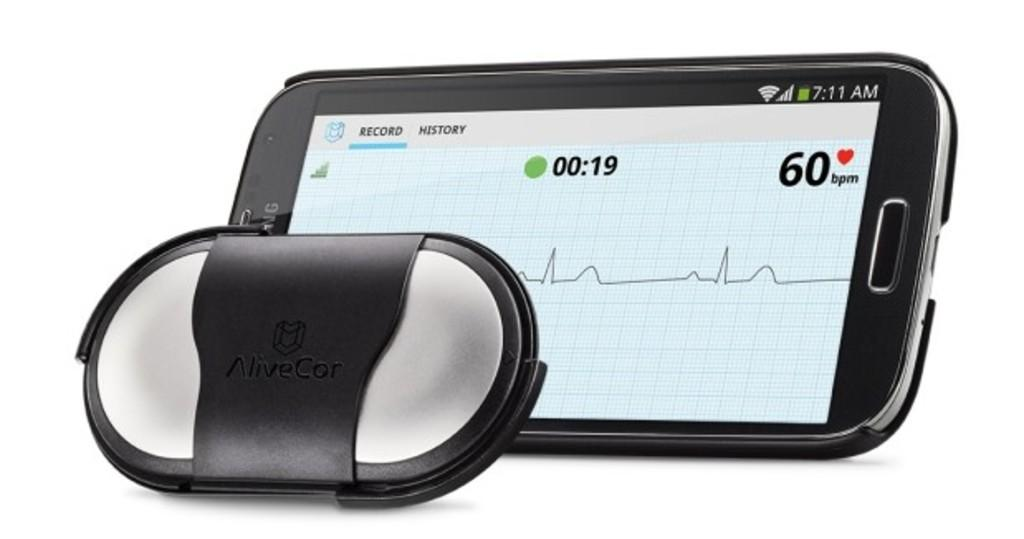<image>
Present a compact description of the photo's key features. AliveCor Electrocardiogram recording app on a cell phone. 